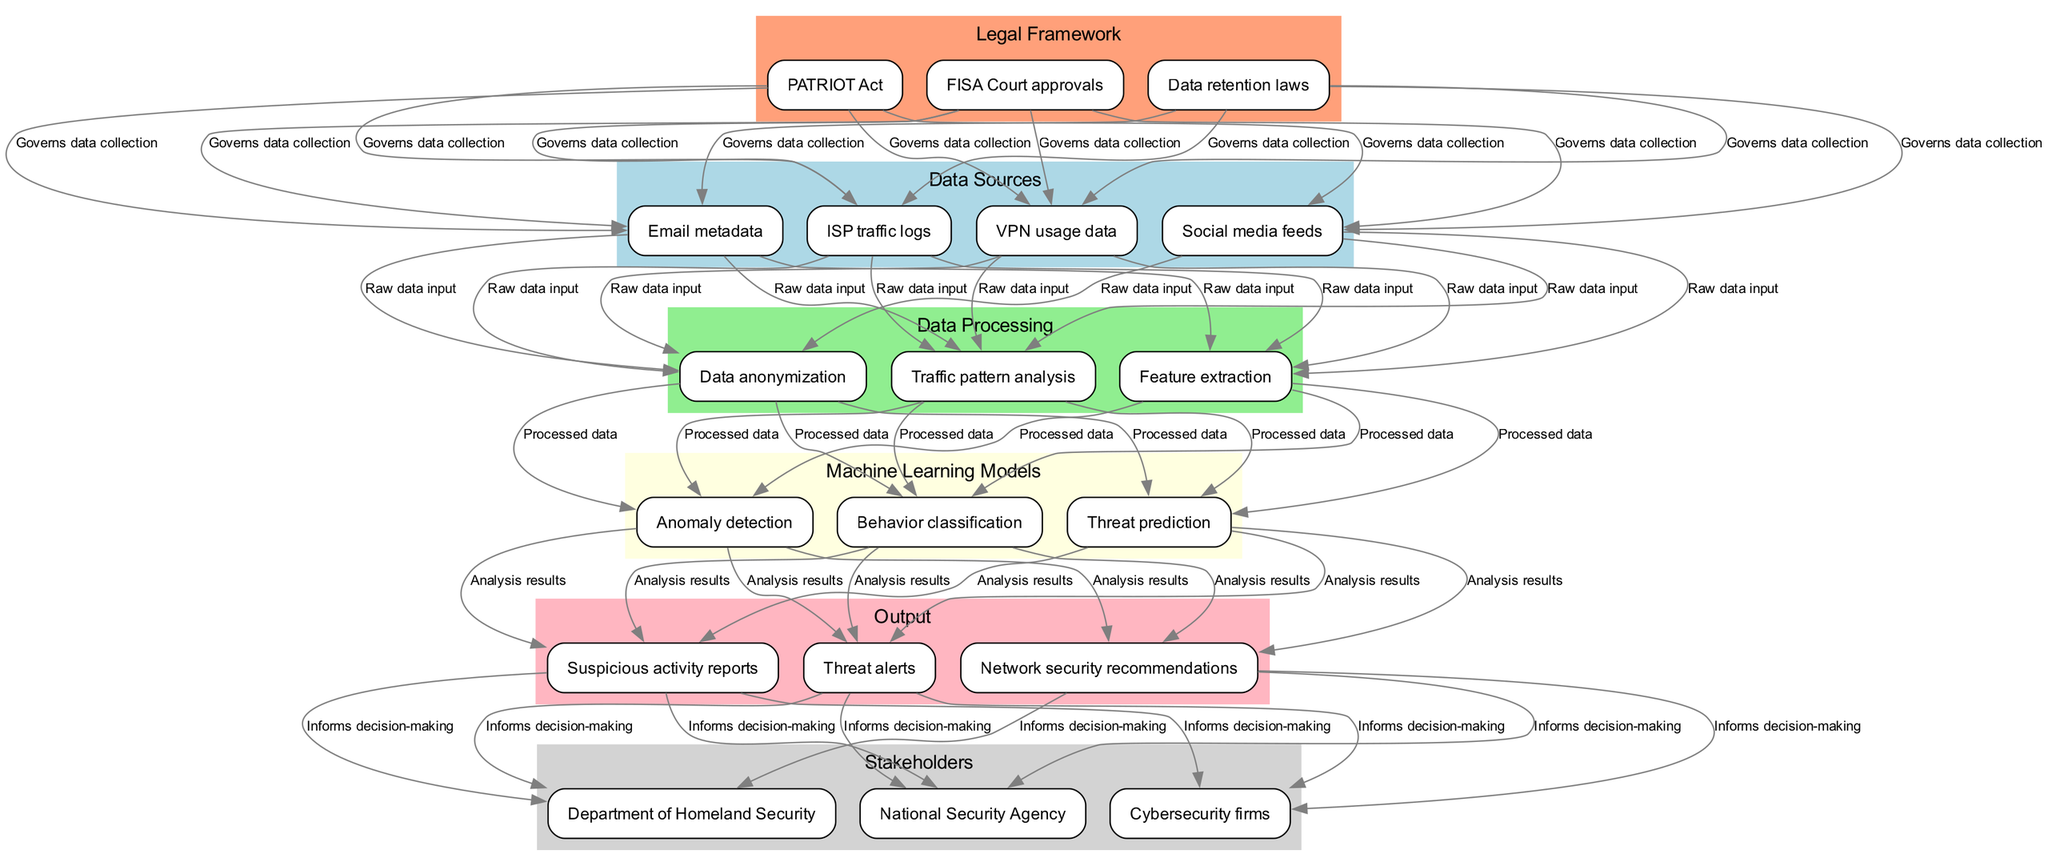What are the data sources in the diagram? The diagram lists "ISP traffic logs," "Social media feeds," "Email metadata," and "VPN usage data" as the data sources. These are included under the "Data Sources" section of the diagram and represent the initial inputs for the pipeline.
Answer: ISP traffic logs, social media feeds, email metadata, VPN usage data How many data processing methods are identified? There are three data processing methods identified in the diagram: "Data anonymization," "Feature extraction," and "Traffic pattern analysis." Counting these methods provides a quick overview of the processing stage of the pipeline.
Answer: 3 Which machine learning model is used to detect anomalies? The diagram explicitly states "Anomaly detection" as one of the machine learning models and labels it under the "Machine Learning Models" section, indicating its purpose in identifying irregular patterns in the data.
Answer: Anomaly detection What informs decision-making in the diagram? The output section mentions "Threat alerts," "Suspicious activity reports," and "Network security recommendations" as results that directly inform decision-making for stakeholders such as the National Security Agency and the Department of Homeland Security.
Answer: Threat alerts, suspicious activity reports, network security recommendations What governs data collection in the proposed machine learning pipeline? The "Legal Framework" section indicates that "PATRIOT Act," "FISA Court approvals," and "Data retention laws" govern data collection, ensuring that the data gathering and analysis processes comply with legal standards.
Answer: PATRIOT Act, FISA Court approvals, data retention laws How is processed data used in the machine learning models? The diagram illustrates a direct connection where "Processed data" flows from the "Data Processing" section to the "Machine Learning Models" section, highlighting that the output of data processing is essential for the application of machine learning techniques.
Answer: Processed data How many stakeholders are mentioned in the diagram? The diagram identifies three stakeholders: "National Security Agency," "Department of Homeland Security," and "Cybersecurity firms," providing insight into who benefits from the analysis and outputs of the machine learning pipeline.
Answer: 3 Which output connects to stakeholders? The outputs listed in the diagram include "Threat alerts," "Suspicious activity reports," and "Network security recommendations." All these outputs serve to connect directly to the stakeholders for informed decision-making.
Answer: Threat alerts, suspicious activity reports, network security recommendations What relationship exists between the legal framework and data sources? The diagram shows that the legal framework governs data collection by connecting the "Legal Framework" section with the "Data Sources" section to ensure compliance when collecting information for analysis.
Answer: Governs data collection 